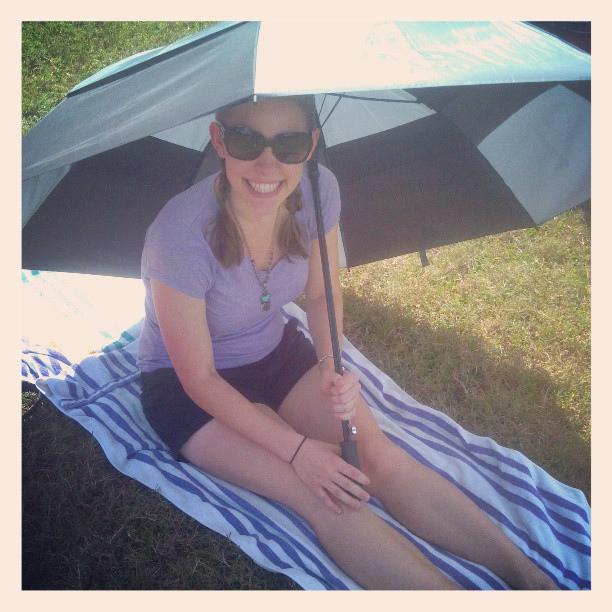What color is the womans umbrella?
Keep it brief. Black. How does the woman have her hair styled?
Quick response, please. Braids. Is it raining?
Short answer required. No. Is the woman sheltering from the rain?
Concise answer only. No. 